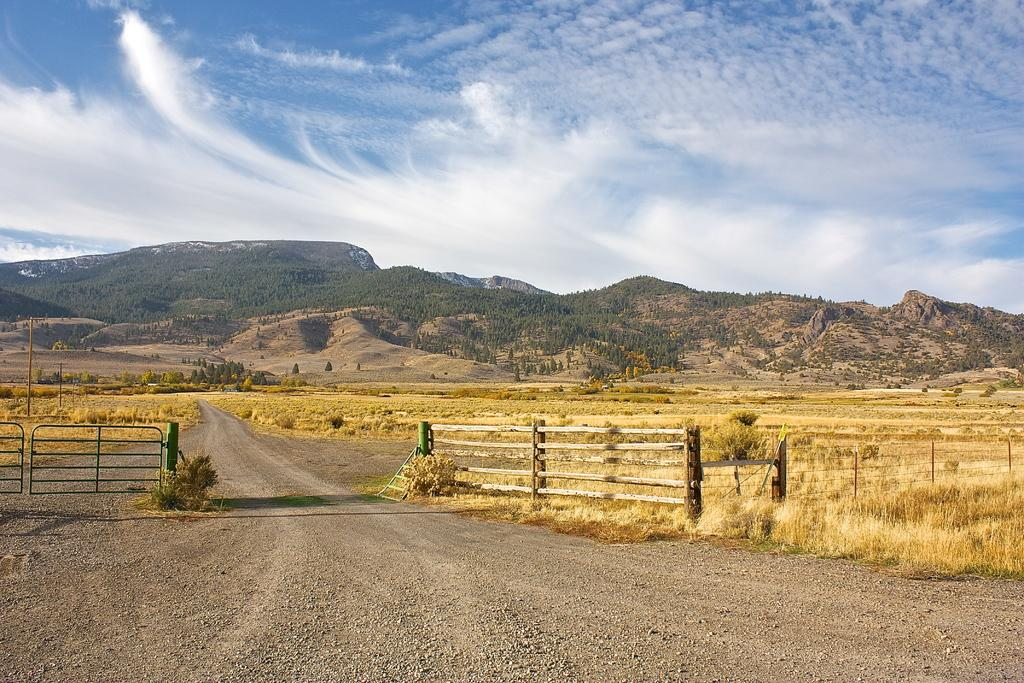What type of surface can be seen in the image? There is a road in the image. What is located near the road? There is a fence in the image. What type of vegetation is present in the image? There is grass and trees in the image. What type of natural landform can be seen in the distance? There are mountains in the image. What is visible in the background of the image? The sky is visible in the background of the image, and clouds are present in the sky. What type of bone can be seen sticking out of the ground in the image? There is no bone present in the image; it features a road, a fence, grass, trees, mountains, and a sky with clouds. What type of steam is coming out of the trees in the image? There is no steam present in the image; it features a road, a fence, grass, trees, mountains, and a sky with clouds. 